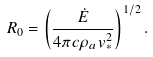Convert formula to latex. <formula><loc_0><loc_0><loc_500><loc_500>R _ { 0 } = \left ( \frac { \dot { E } } { 4 \pi c \rho _ { a } v ^ { 2 } _ { \ast } } \right ) ^ { 1 / 2 } .</formula> 